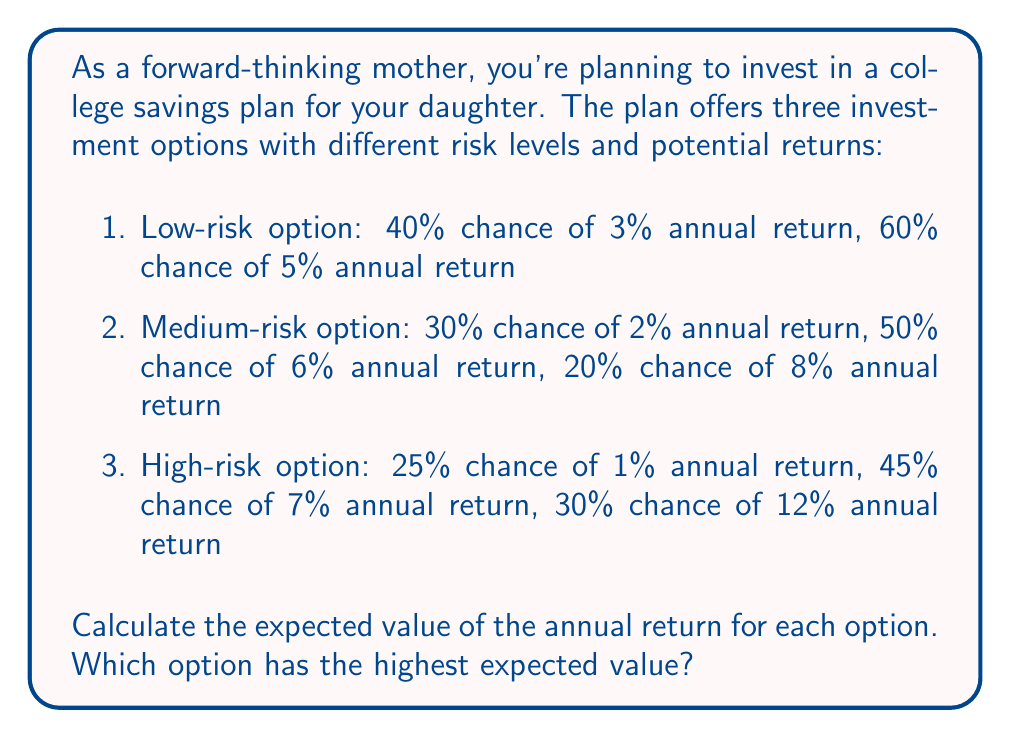Solve this math problem. To calculate the expected value for each option, we'll multiply each possible outcome by its probability and sum the results.

1. Low-risk option:
   $E(\text{low-risk}) = (0.40 \times 0.03) + (0.60 \times 0.05)$
   $= 0.012 + 0.030 = 0.042$ or 4.2%

2. Medium-risk option:
   $E(\text{medium-risk}) = (0.30 \times 0.02) + (0.50 \times 0.06) + (0.20 \times 0.08)$
   $= 0.006 + 0.030 + 0.016 = 0.052$ or 5.2%

3. High-risk option:
   $E(\text{high-risk}) = (0.25 \times 0.01) + (0.45 \times 0.07) + (0.30 \times 0.12)$
   $= 0.0025 + 0.0315 + 0.0360 = 0.0700$ or 7.0%

Comparing the expected values:
Low-risk: 4.2%
Medium-risk: 5.2%
High-risk: 7.0%

The high-risk option has the highest expected value of 7.0%.
Answer: The high-risk option has the highest expected value at 7.0%. 